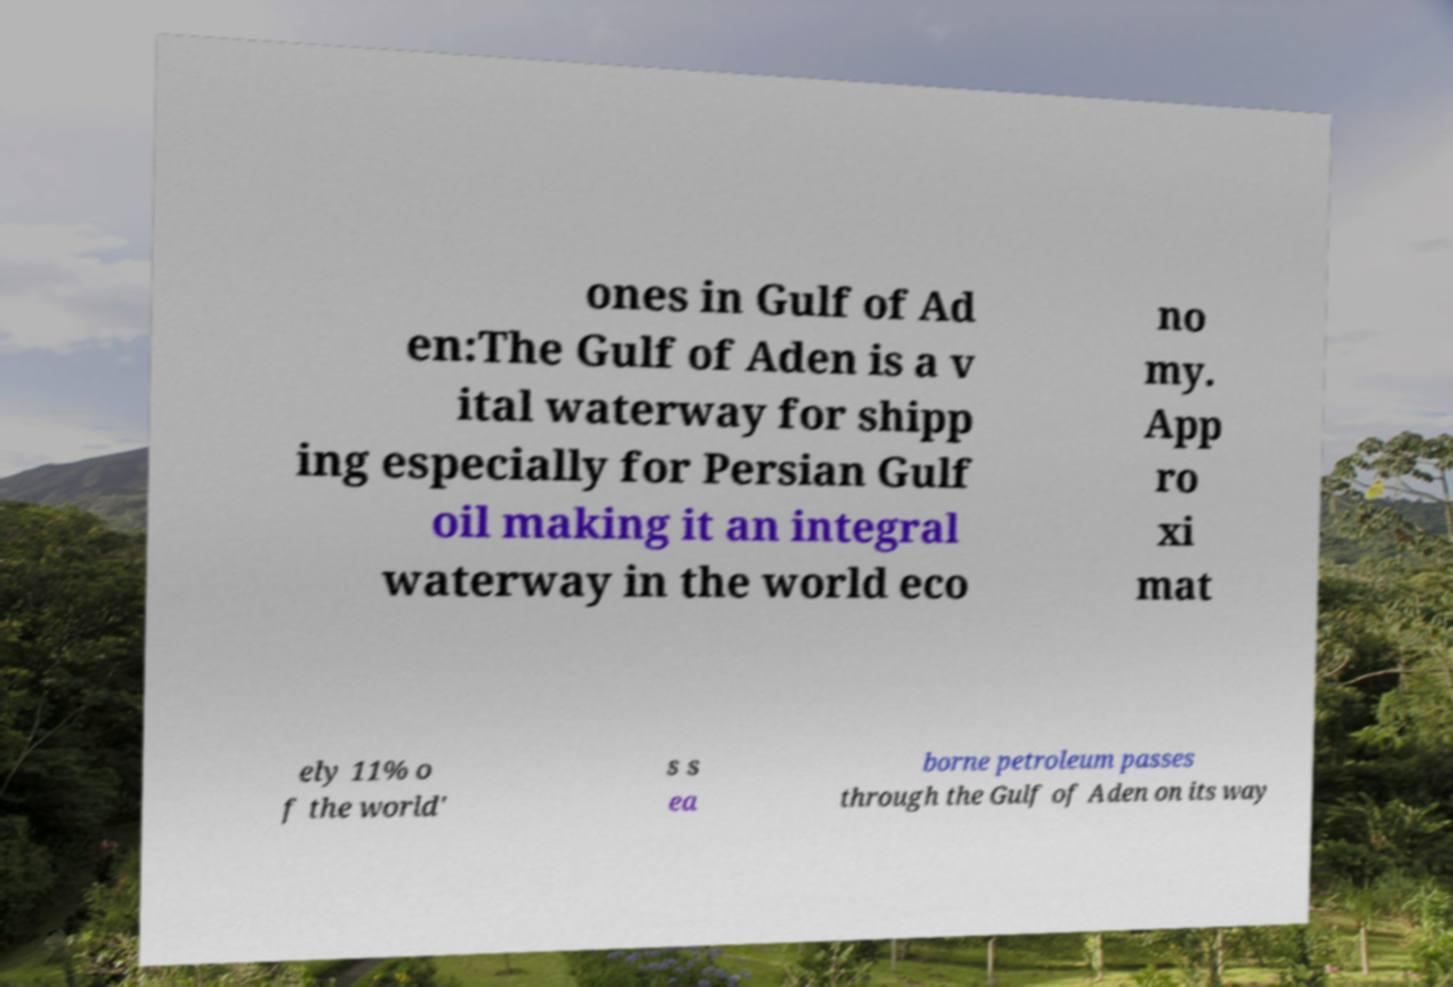Can you read and provide the text displayed in the image?This photo seems to have some interesting text. Can you extract and type it out for me? ones in Gulf of Ad en:The Gulf of Aden is a v ital waterway for shipp ing especially for Persian Gulf oil making it an integral waterway in the world eco no my. App ro xi mat ely 11% o f the world' s s ea borne petroleum passes through the Gulf of Aden on its way 